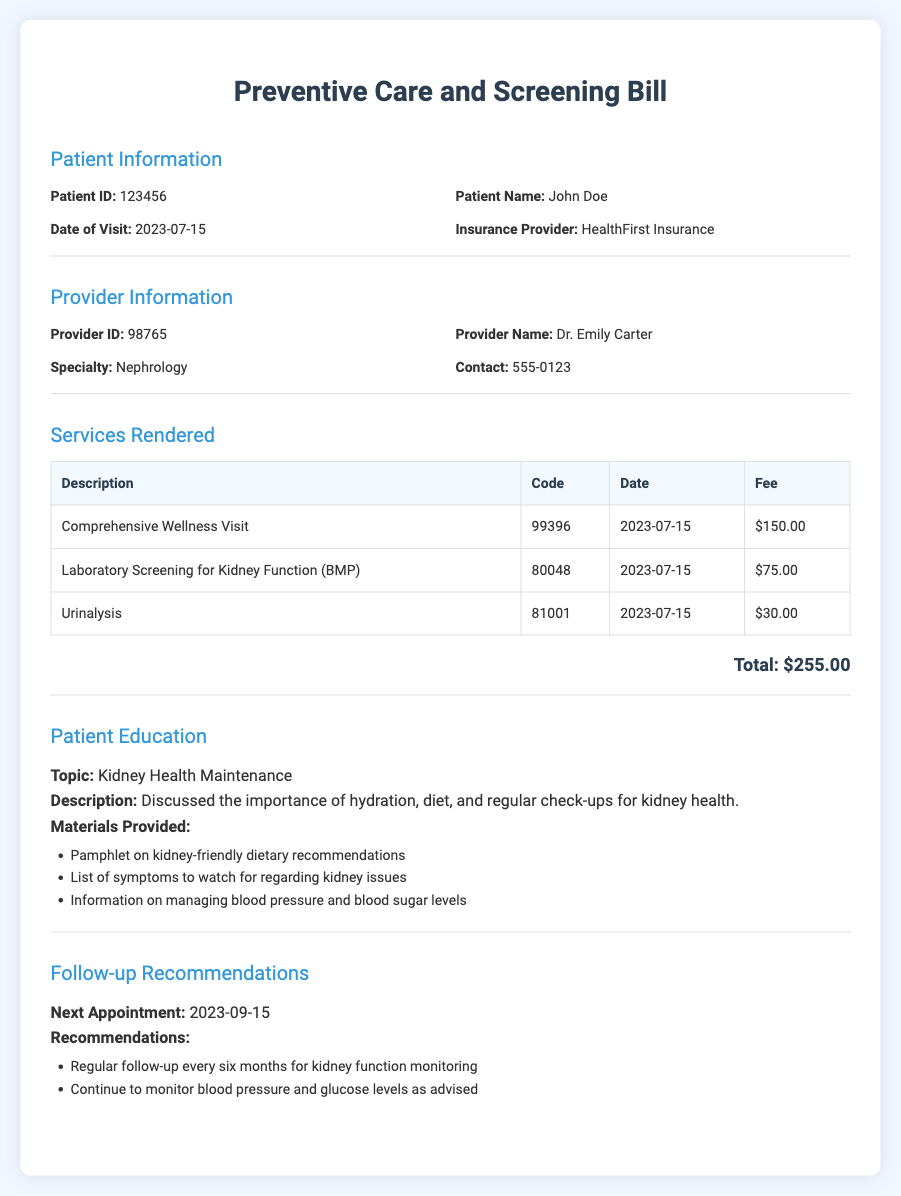What is the patient ID? The patient ID is listed in the document under Patient Information.
Answer: 123456 Who is the provider for this patient? The provider's name is mentioned in the Provider Information section.
Answer: Dr. Emily Carter What date was the visit? The date of the visit is specified in the Patient Information section.
Answer: 2023-07-15 What is the total fee for the services rendered? The total fee is provided at the end of the Services Rendered section, representing the sum of all fees.
Answer: $255.00 What is one of the topics discussed in patient education? The document lists topics under Patient Education that were discussed with the patient.
Answer: Kidney Health Maintenance When is the next appointment scheduled? The date of the next appointment is found in the Follow-up Recommendations section.
Answer: 2023-09-15 What is the code for the laboratory screening for kidney function? The billing code for this service is provided in the Services Rendered section.
Answer: 80048 Which insurance provider is associated with this patient? The insurance provider's name is found in the Patient Information section.
Answer: HealthFirst Insurance What recommendations are made for follow-up? The follow-up recommendations specify actions or checks for the patient to take.
Answer: Regular follow-up every six months for kidney function monitoring 